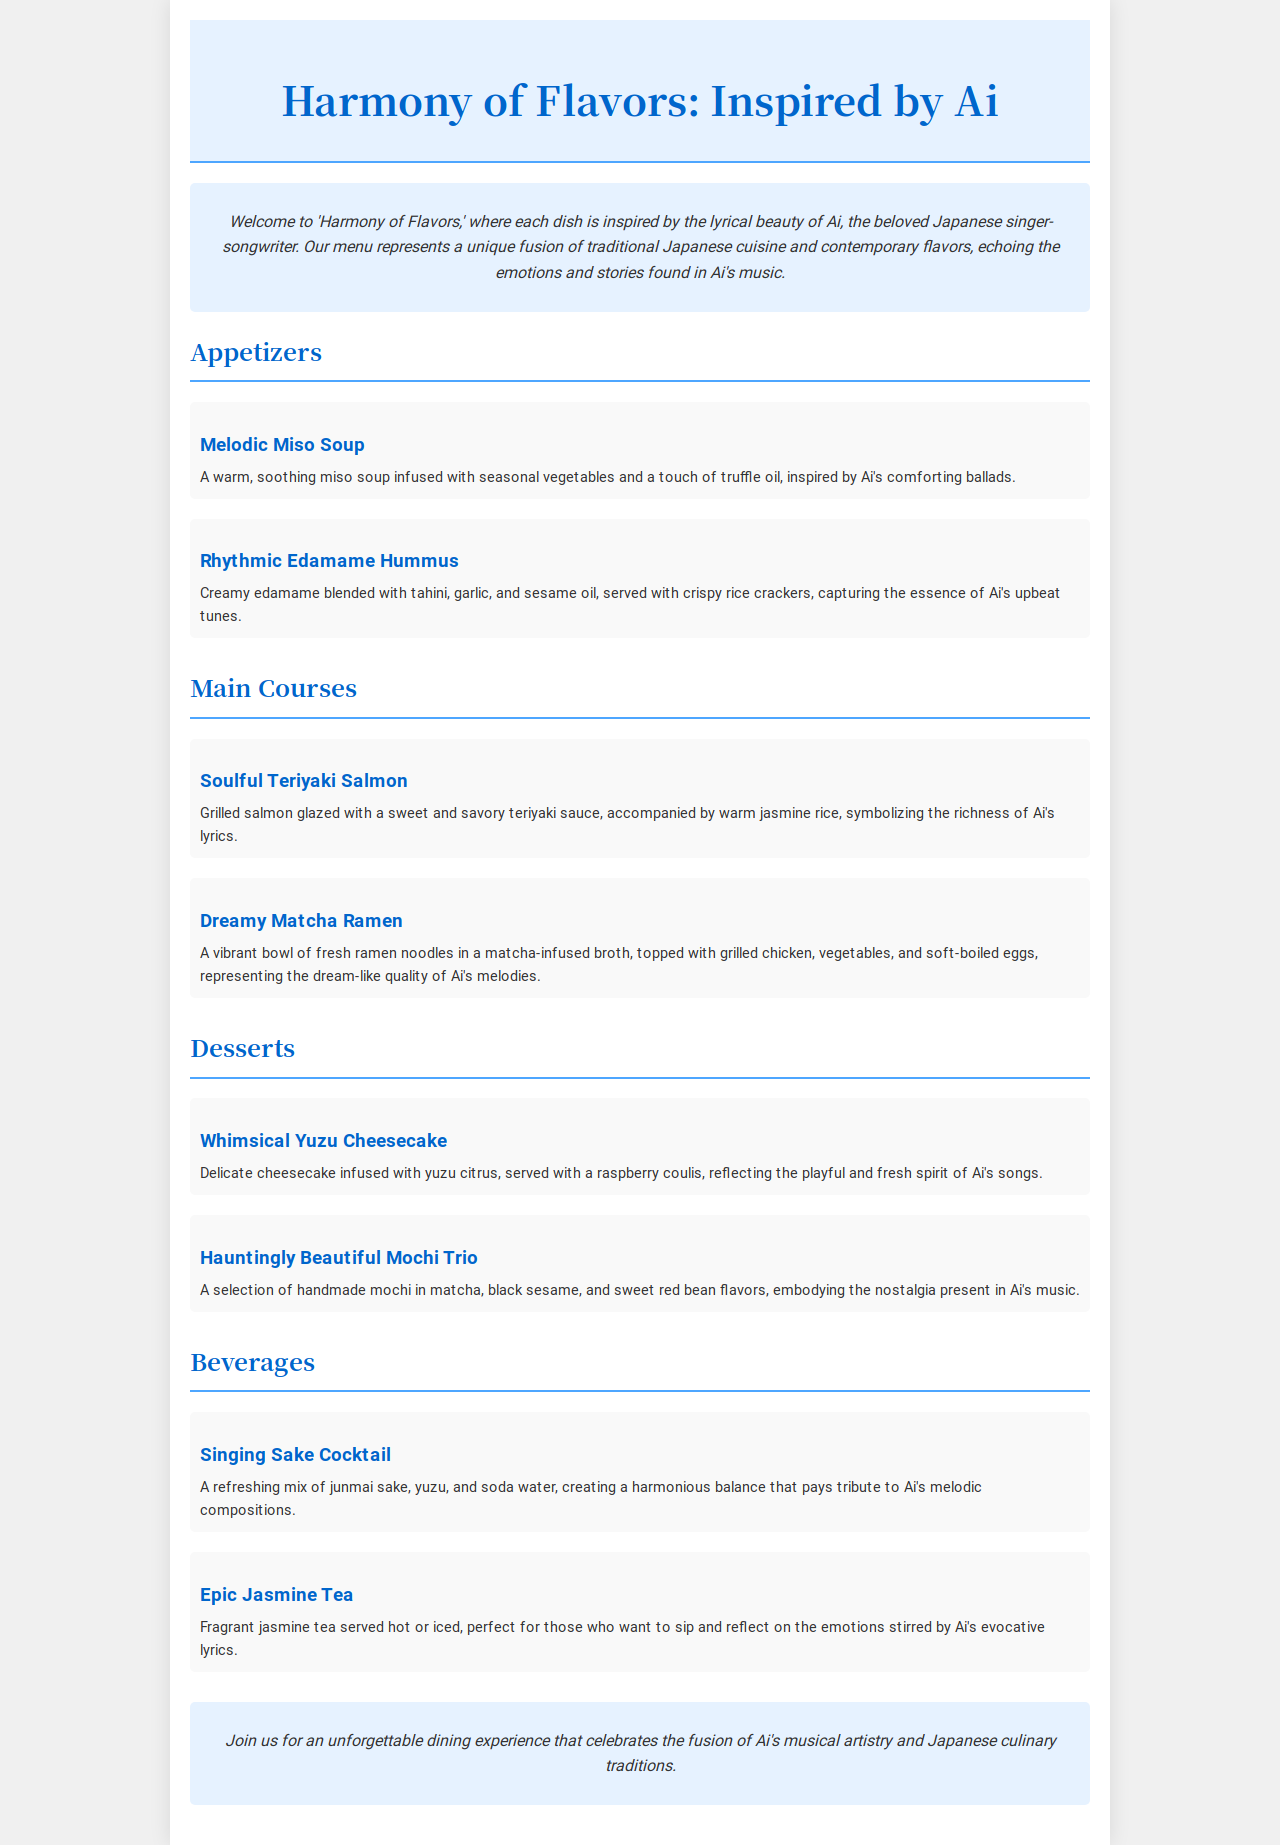What is the name of the restaurant? The name of the restaurant is mentioned in the header of the document, which is "Harmony of Flavors: Inspired by Ai."
Answer: Harmony of Flavors: Inspired by Ai Which dish features matcha? The dish that features matcha is provided under the main courses section, specifically "Dreamy Matcha Ramen."
Answer: Dreamy Matcha Ramen How many appetizers are listed? The document has a menu section for appetizers, which includes two items: "Melodic Miso Soup" and "Rhythmic Edamame Hummus."
Answer: 2 What beverage is inspired by Ai's melodic compositions? The beverage that pays tribute to Ai's melodies is stated as "Singing Sake Cocktail."
Answer: Singing Sake Cocktail What flavors are present in the mochi trio? The description of the "Hauntingly Beautiful Mochi Trio" mentions three flavors: matcha, black sesame, and sweet red bean.
Answer: matcha, black sesame, and sweet red bean What is the main theme of the menu? The introduction provides insight into the menu's theme, focusing on a fusion of flavors inspired by Ai's music and lyrics.
Answer: Japanese Fusion Cuisine Inspired by Ai's Lyrics What is the price range for the dishes? There is no mention of prices in the document, which typically can be considered when analyzing the menu.
Answer: Not specified Which dish reflects playful themes? The "Whimsical Yuzu Cheesecake" is described as reflecting the playful spirit of Ai's songs in the desserts section.
Answer: Whimsical Yuzu Cheesecake 